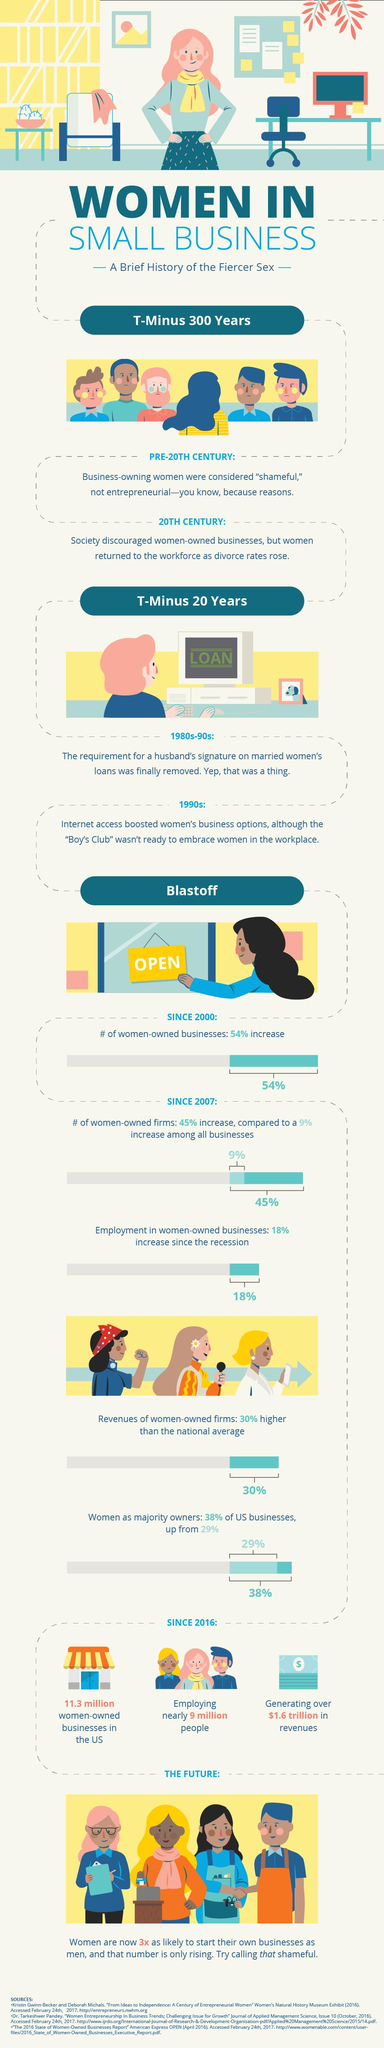Draw attention to some important aspects in this diagram. After June 2009, there was a 18% increase in women-owned businesses. 